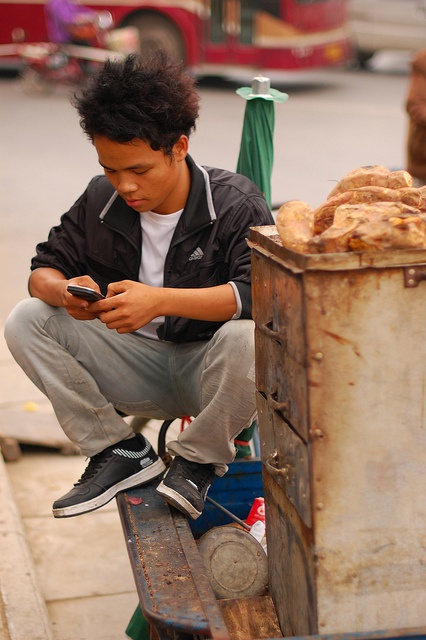Describe the objects in this image and their specific colors. I can see people in brown, black, and gray tones, bus in brown, maroon, and gray tones, truck in brown, maroon, and gray tones, umbrella in brown, darkgreen, and teal tones, and cell phone in brown, black, maroon, and gray tones in this image. 